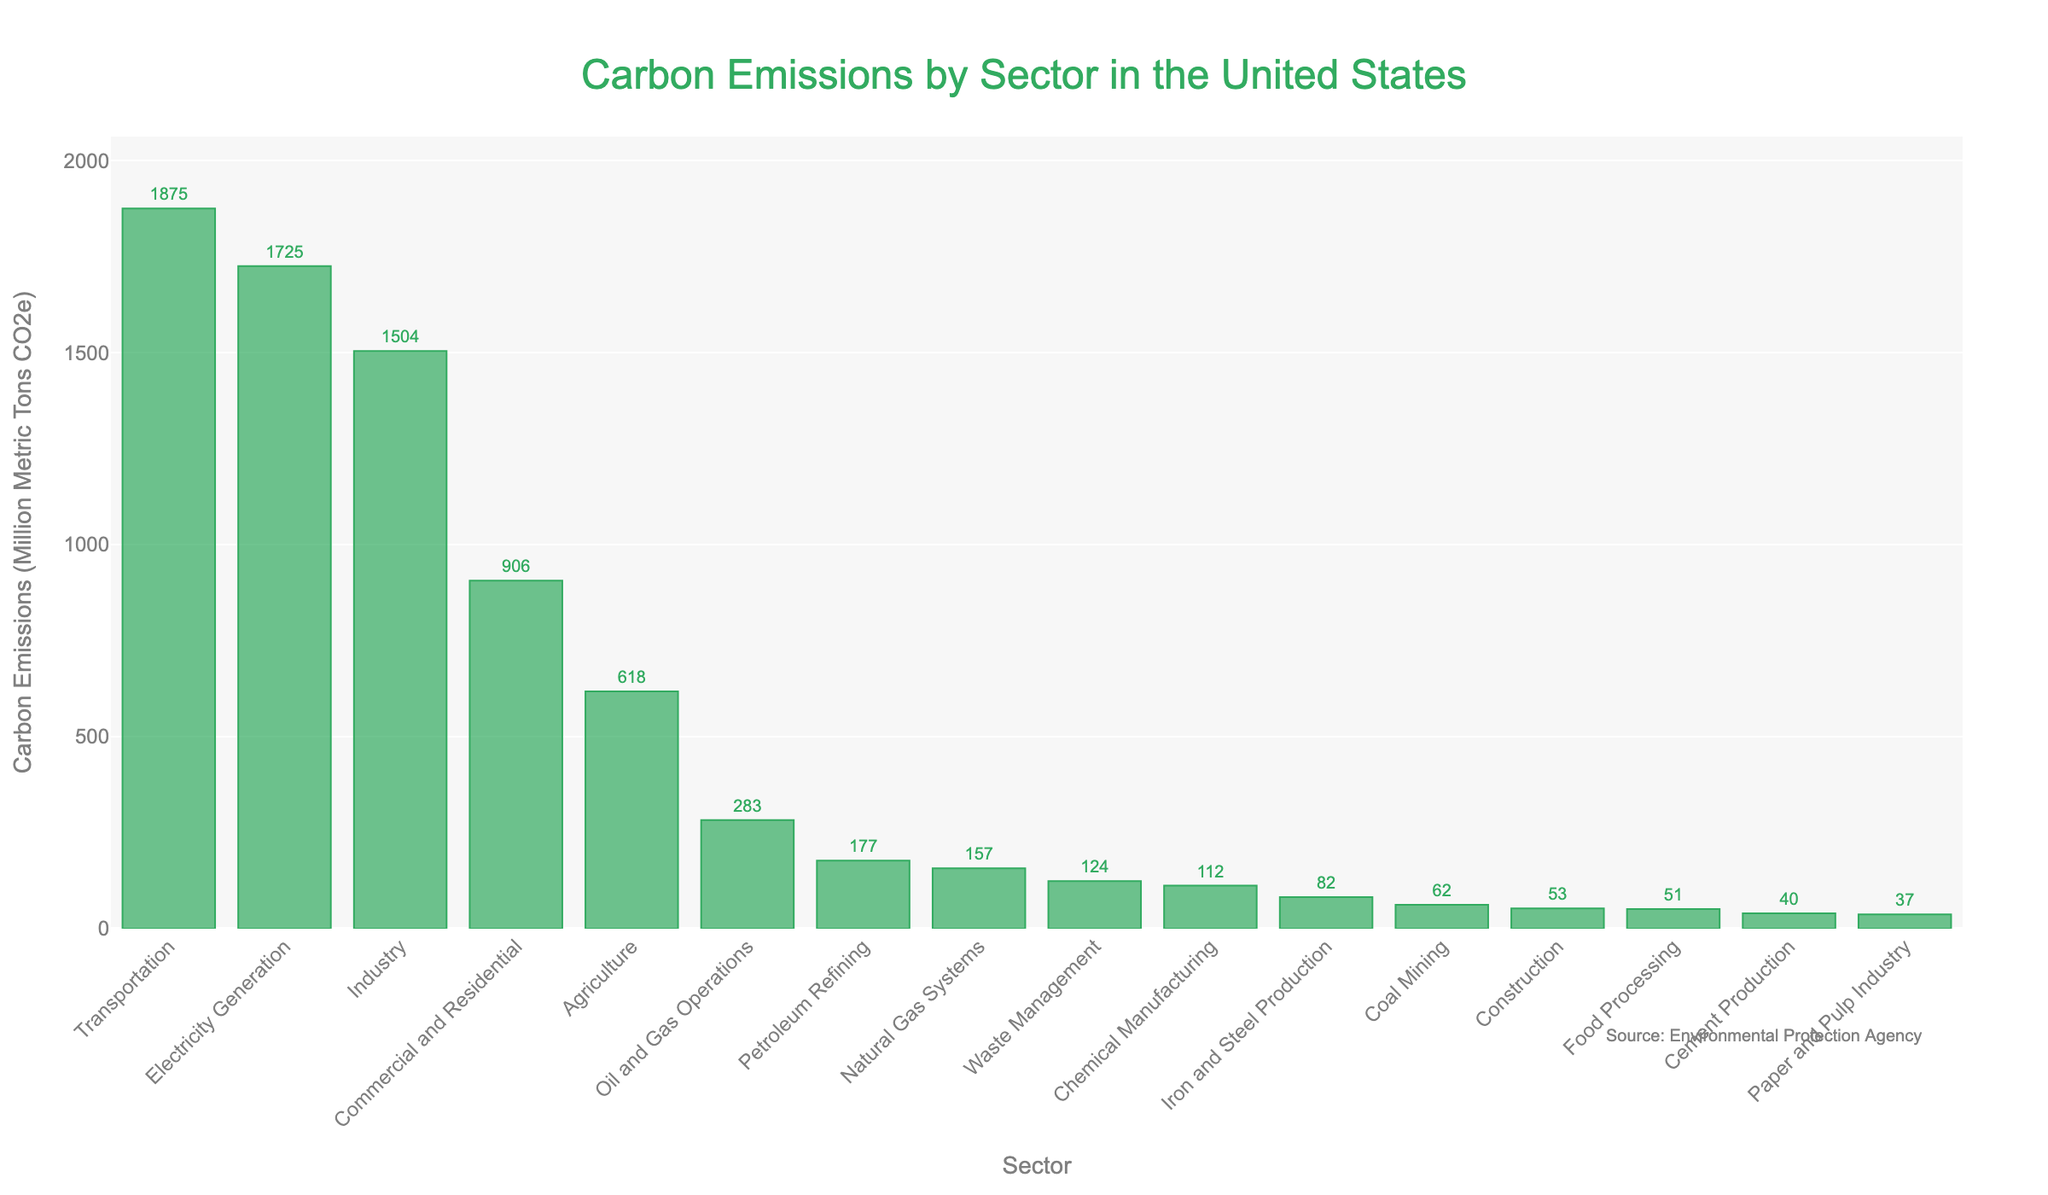What is the sector with the highest carbon emissions? By looking at the bar chart, the tallest bar represents the Transportation sector, indicating it has the highest carbon emissions.
Answer: Transportation How much more carbon emissions does the Transportation sector produce compared to the Electricity Generation sector? The bar for Transportation shows 1875 million metric tons CO2e, and the bar for Electricity Generation shows 1725 million metric tons CO2e. The difference is 1875 - 1725 = 150 million metric tons CO2e.
Answer: 150 Which sector has the lowest carbon emissions? The shortest bar represents the Paper and Pulp Industry sector, indicating it has the lowest carbon emissions.
Answer: Paper and Pulp Industry What is the total carbon emissions from the Oil and Gas Operations, Coal Mining, and Waste Management sectors? Adding the values for these sectors: Oil and Gas Operations (283), Coal Mining (62), and Waste Management (124), the total is 283 + 62 + 124 = 469 million metric tons CO2e.
Answer: 469 Among the Iron and Steel Production, Cement Production, and Chemical Manufacturing, which sector has the highest carbon emissions? Comparing the bars for these sectors, Chemical Manufacturing (112) has higher carbon emissions than Iron and Steel Production (82) and Cement Production (40).
Answer: Chemical Manufacturing How do the carbon emissions from the Agriculture sector compare to those from the Industry sector? The bar for Agriculture shows 618 million metric tons CO2e, and the Industry sector has 1504 million metric tons CO2e. The Industry sector's emissions are significantly higher than those from Agriculture.
Answer: Industry sector is higher What is the combined carbon emissions from Commercial and Residential and Petroleum Refining sectors? Adding the values for these sectors: Commercial and Residential (906) and Petroleum Refining (177), the combined emissions are 906 + 177 = 1083 million metric tons CO2e.
Answer: 1083 What are the sectors with carbon emissions less than 100 million metric tons CO2e? By examining the bars with heights below the 100 million metric tons CO2e marker, these sectors are: Coal Mining (62), Iron and Steel Production (82), Cement Production (40), Paper and Pulp Industry (37), Food Processing (51), and Construction (53).
Answer: Coal Mining, Iron and Steel Production, Cement Production, Paper and Pulp Industry, Food Processing, Construction 